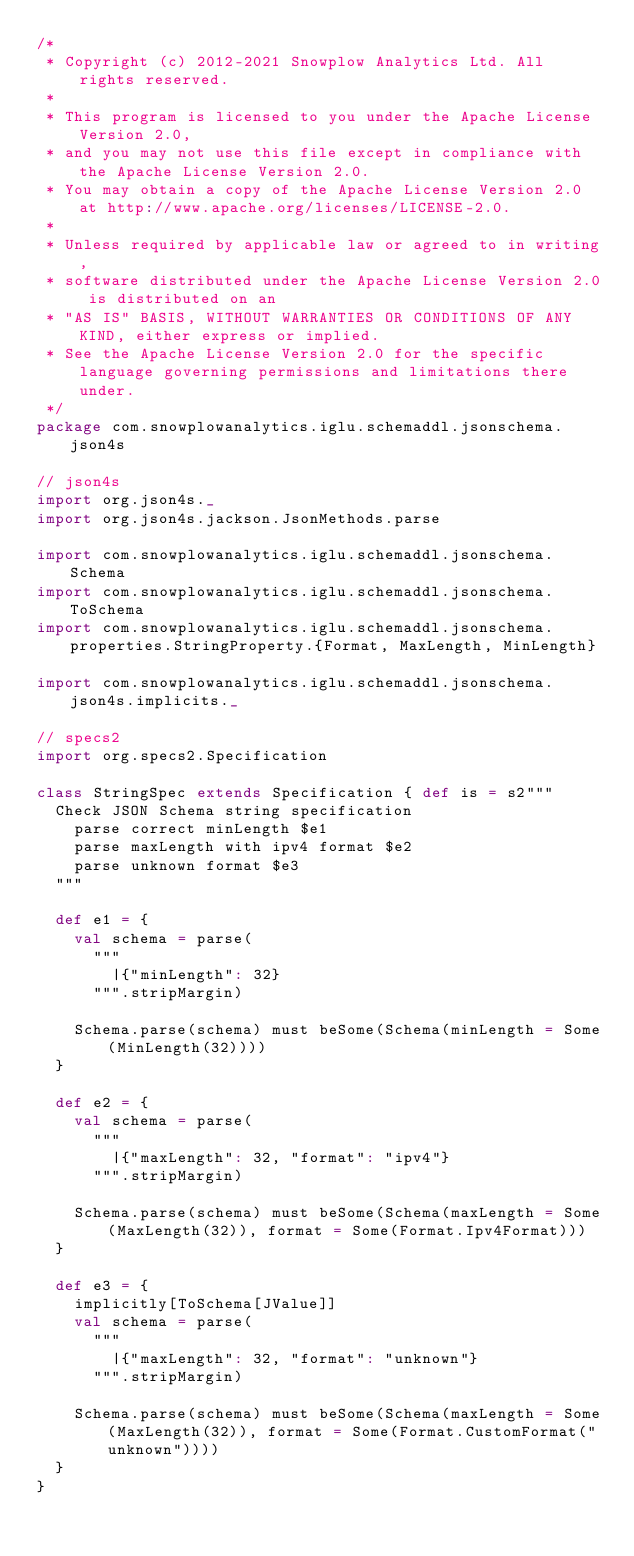<code> <loc_0><loc_0><loc_500><loc_500><_Scala_>/*
 * Copyright (c) 2012-2021 Snowplow Analytics Ltd. All rights reserved.
 *
 * This program is licensed to you under the Apache License Version 2.0,
 * and you may not use this file except in compliance with the Apache License Version 2.0.
 * You may obtain a copy of the Apache License Version 2.0 at http://www.apache.org/licenses/LICENSE-2.0.
 *
 * Unless required by applicable law or agreed to in writing,
 * software distributed under the Apache License Version 2.0 is distributed on an
 * "AS IS" BASIS, WITHOUT WARRANTIES OR CONDITIONS OF ANY KIND, either express or implied.
 * See the Apache License Version 2.0 for the specific language governing permissions and limitations there under.
 */
package com.snowplowanalytics.iglu.schemaddl.jsonschema.json4s

// json4s
import org.json4s._
import org.json4s.jackson.JsonMethods.parse

import com.snowplowanalytics.iglu.schemaddl.jsonschema.Schema
import com.snowplowanalytics.iglu.schemaddl.jsonschema.ToSchema
import com.snowplowanalytics.iglu.schemaddl.jsonschema.properties.StringProperty.{Format, MaxLength, MinLength}

import com.snowplowanalytics.iglu.schemaddl.jsonschema.json4s.implicits._

// specs2
import org.specs2.Specification

class StringSpec extends Specification { def is = s2"""
  Check JSON Schema string specification
    parse correct minLength $e1
    parse maxLength with ipv4 format $e2
    parse unknown format $e3
  """

  def e1 = {
    val schema = parse(
      """
        |{"minLength": 32}
      """.stripMargin)

    Schema.parse(schema) must beSome(Schema(minLength = Some(MinLength(32))))
  }

  def e2 = {
    val schema = parse(
      """
        |{"maxLength": 32, "format": "ipv4"}
      """.stripMargin)

    Schema.parse(schema) must beSome(Schema(maxLength = Some(MaxLength(32)), format = Some(Format.Ipv4Format)))
  }

  def e3 = {
    implicitly[ToSchema[JValue]]
    val schema = parse(
      """
        |{"maxLength": 32, "format": "unknown"}
      """.stripMargin)

    Schema.parse(schema) must beSome(Schema(maxLength = Some(MaxLength(32)), format = Some(Format.CustomFormat("unknown"))))
  }
}
</code> 